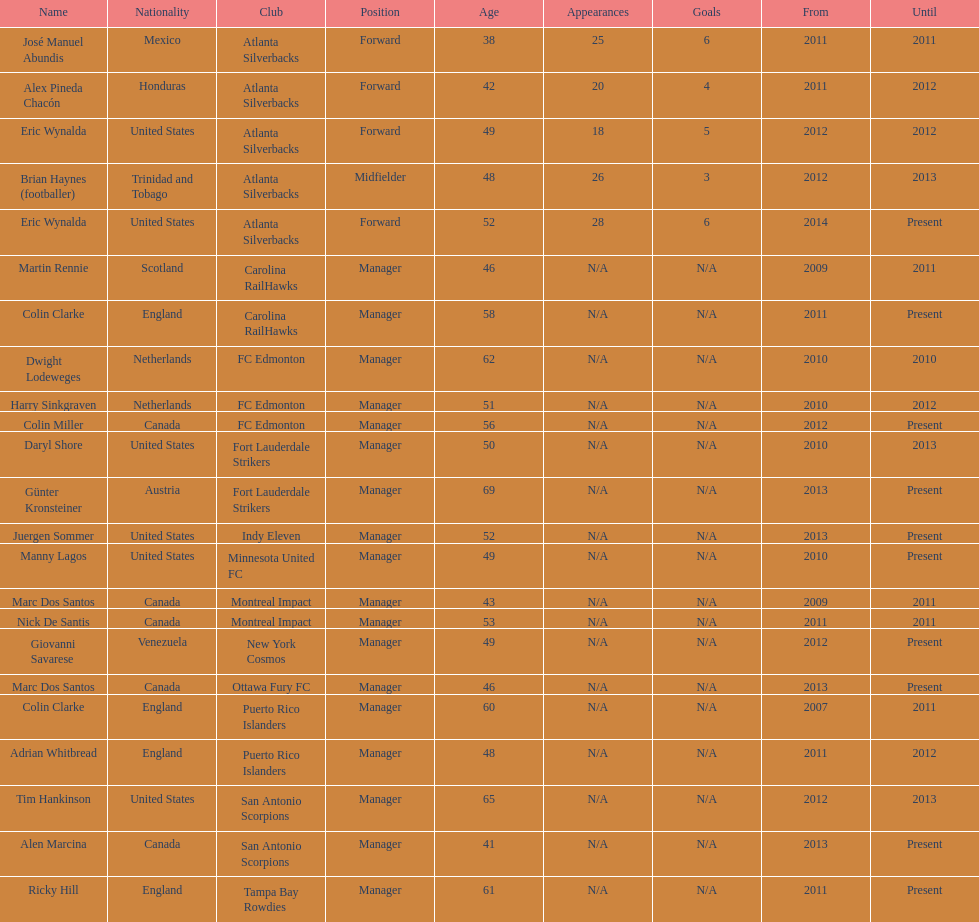What name is listed at the top? José Manuel Abundis. 